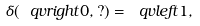<formula> <loc_0><loc_0><loc_500><loc_500>\delta ( \ q v r i g h t { 0 } , ? ) = \ q v l e f t { 1 } ,</formula> 